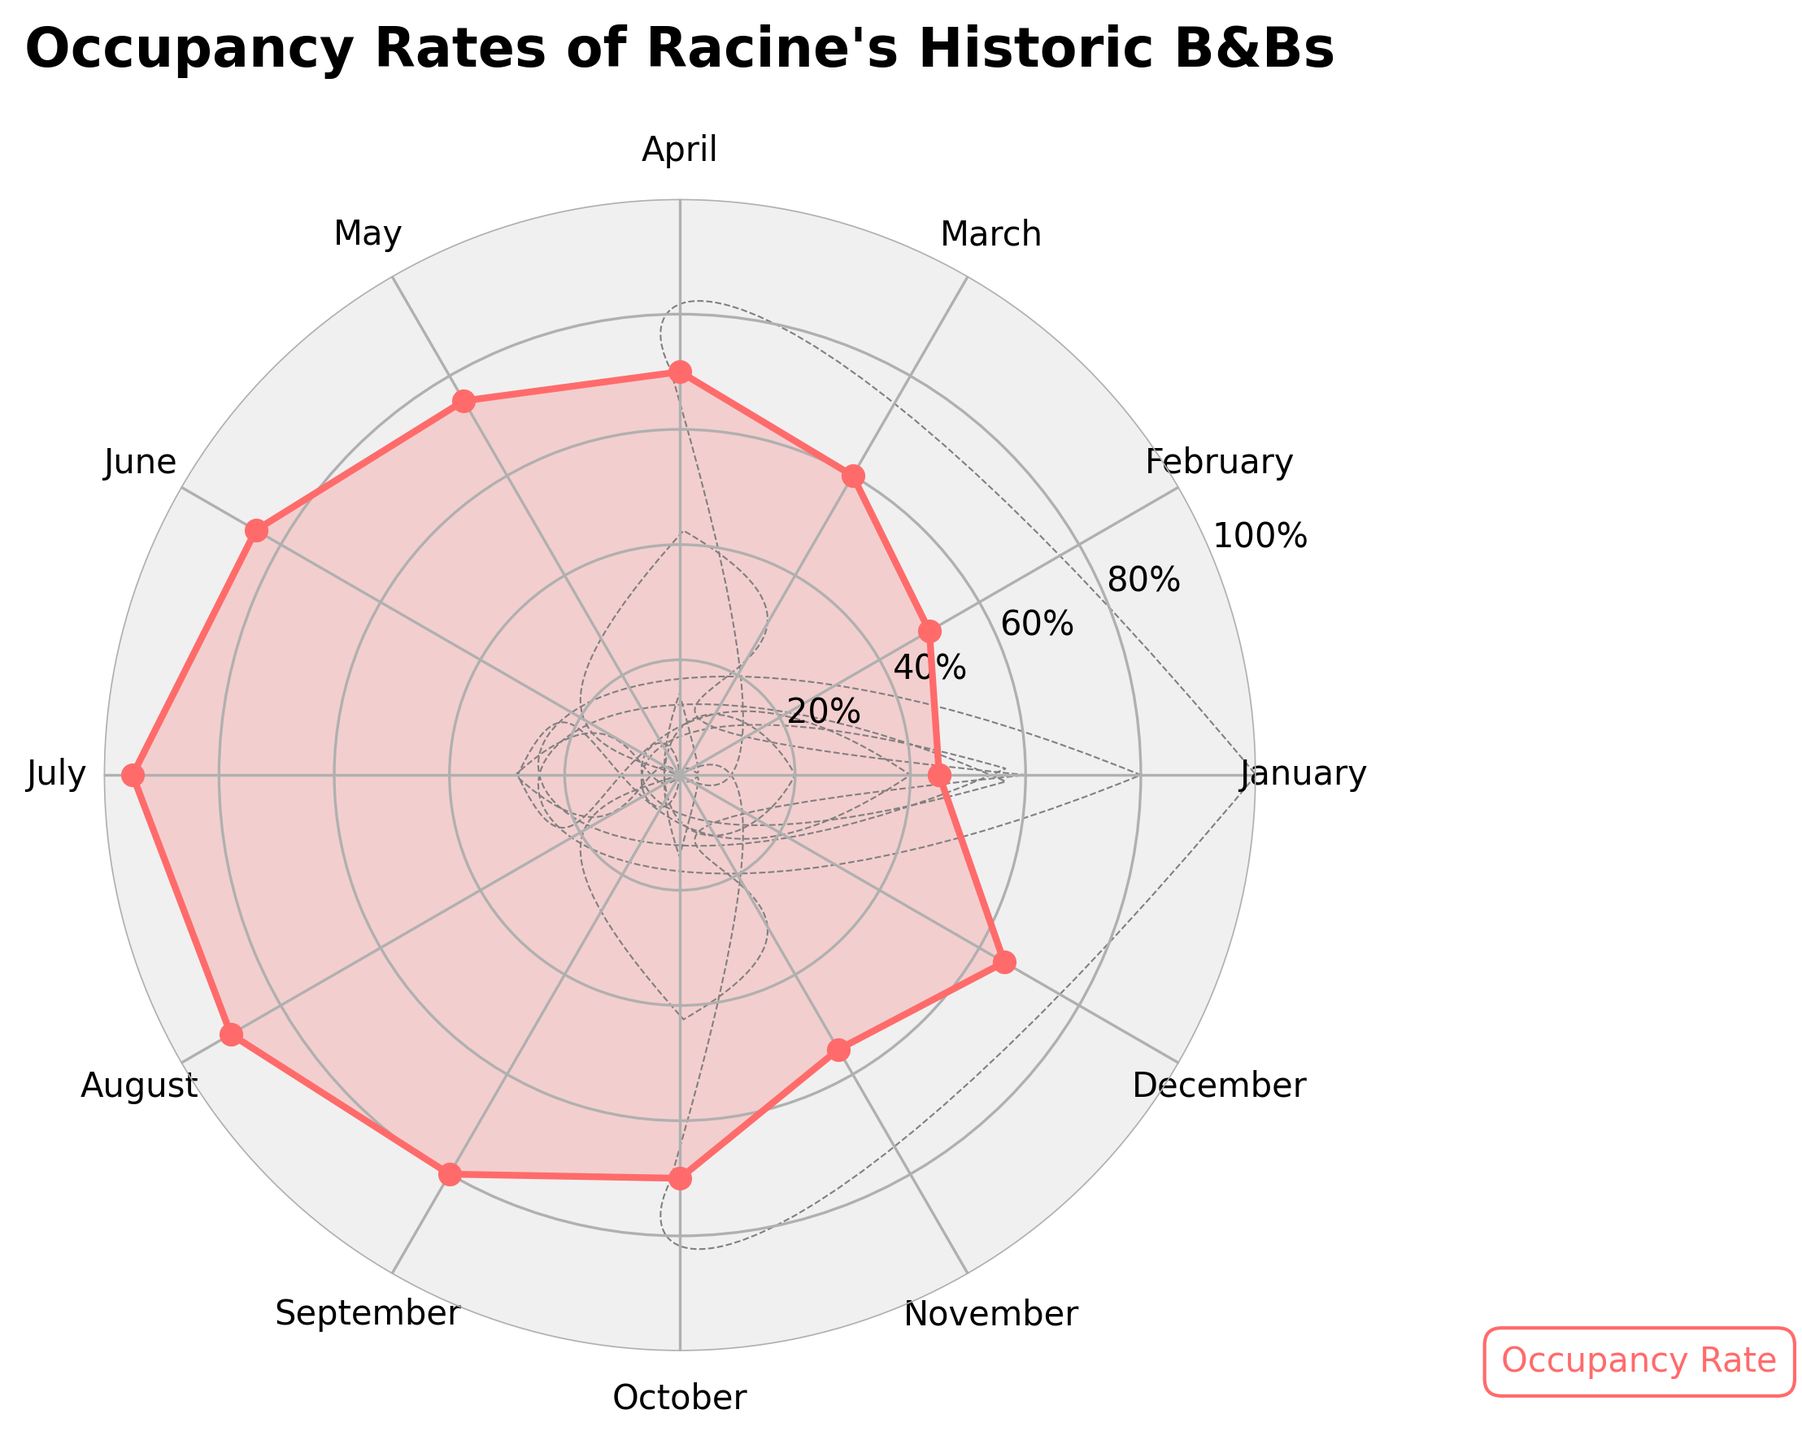what is the highest occupancy rate month? Locate the peak point on the graph which touches the highest y-axis value. Check the corresponding label on the x-axis to identify the month
Answer: July what is the overall trend in the occupancy rate throughout the year? Examine the direction of the lines connecting the datapoints from January through December. The occupancy rate generally increases from January to July, slightly decreases in August, and then varies more in the later months
Answer: Generally increasing up to July, then varies which months have an occupancy rate above 80%? Locate the datapoints that reach above the 80% y-axis value and check the corresponding months on the x-axis
Answer: June, July, August, September how much higher is the occupancy rate in June compared to April? Note the occupancy rate values for June (85%) and April (70%). Subtract the rate for April from June
Answer: 15% what is the average occupancy rate for the first half of the year? Sum the occupancy rates for January through June (45% + 50% + 60% + 70% + 75% + 85%), then divide by 6
Answer: 64.17% What is the total change in occupancy rate from January to December? Find the difference between the occupancy rate in January (45%) and December (65%)
Answer: 20% which month had the lowest occupancy rate? Identify the lowest point on the graph which touches the minimum y-axis value and check the corresponding label on the x-axis
Answer: January what is the difference between the highest and lowest occupancy rates? Identify the highest occupancy rate (95% in July) and lowest (45% in January), then calculate the difference
Answer: 50% How does the occupancy rate in October compare to May? Identify the occupancy rates for October (70%) and May (75%), then determine which is higher
Answer: May is higher by 5% When does the occupancy rate first exceed 70%? Traverse through the data points from January onwards and identify the month where the occupancy rate exceeds 70%
Answer: April 